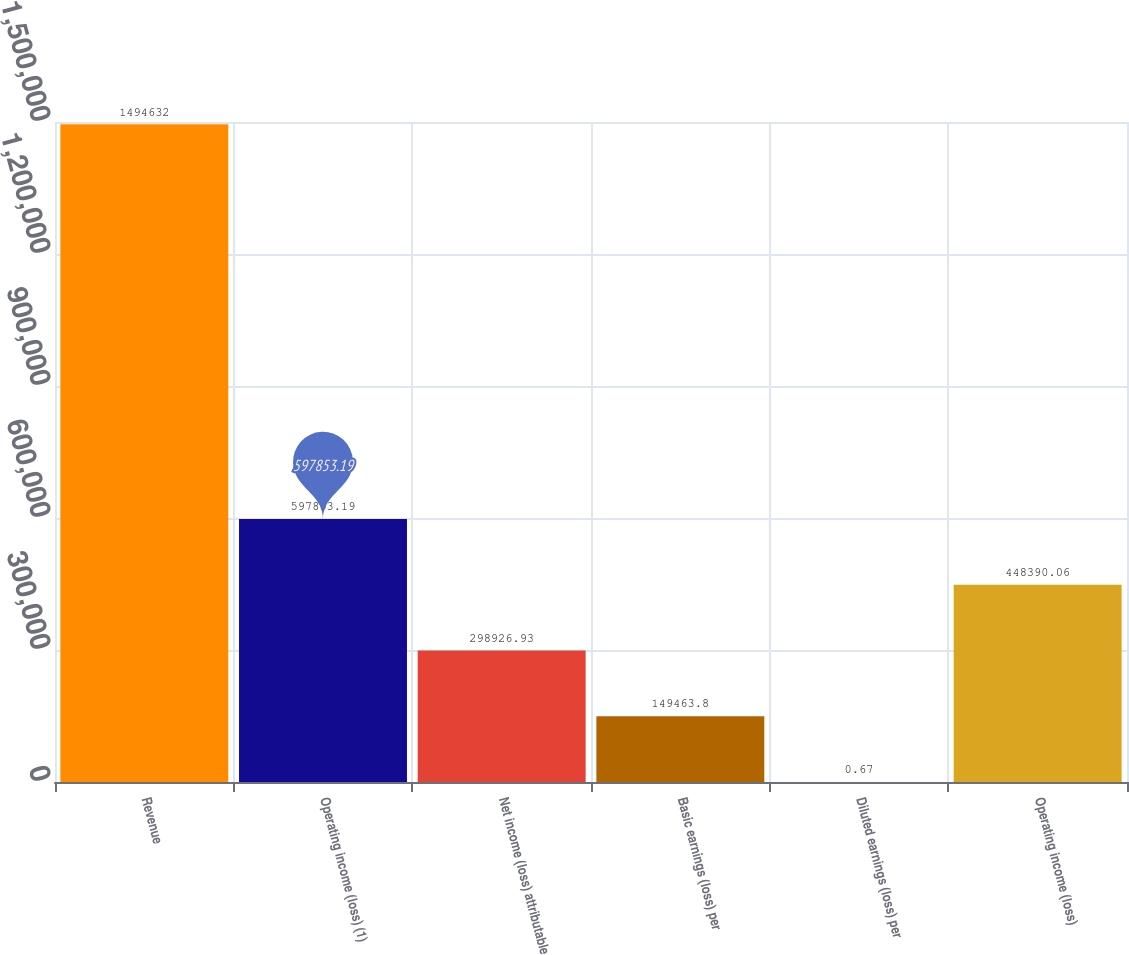<chart> <loc_0><loc_0><loc_500><loc_500><bar_chart><fcel>Revenue<fcel>Operating income (loss) (1)<fcel>Net income (loss) attributable<fcel>Basic earnings (loss) per<fcel>Diluted earnings (loss) per<fcel>Operating income (loss)<nl><fcel>1.49463e+06<fcel>597853<fcel>298927<fcel>149464<fcel>0.67<fcel>448390<nl></chart> 